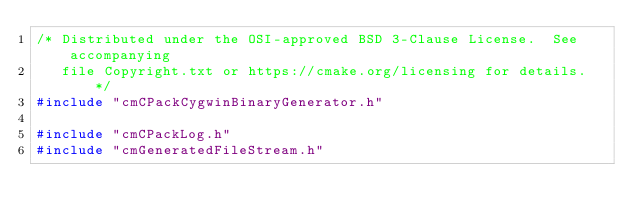<code> <loc_0><loc_0><loc_500><loc_500><_C++_>/* Distributed under the OSI-approved BSD 3-Clause License.  See accompanying
   file Copyright.txt or https://cmake.org/licensing for details.  */
#include "cmCPackCygwinBinaryGenerator.h"

#include "cmCPackLog.h"
#include "cmGeneratedFileStream.h"</code> 